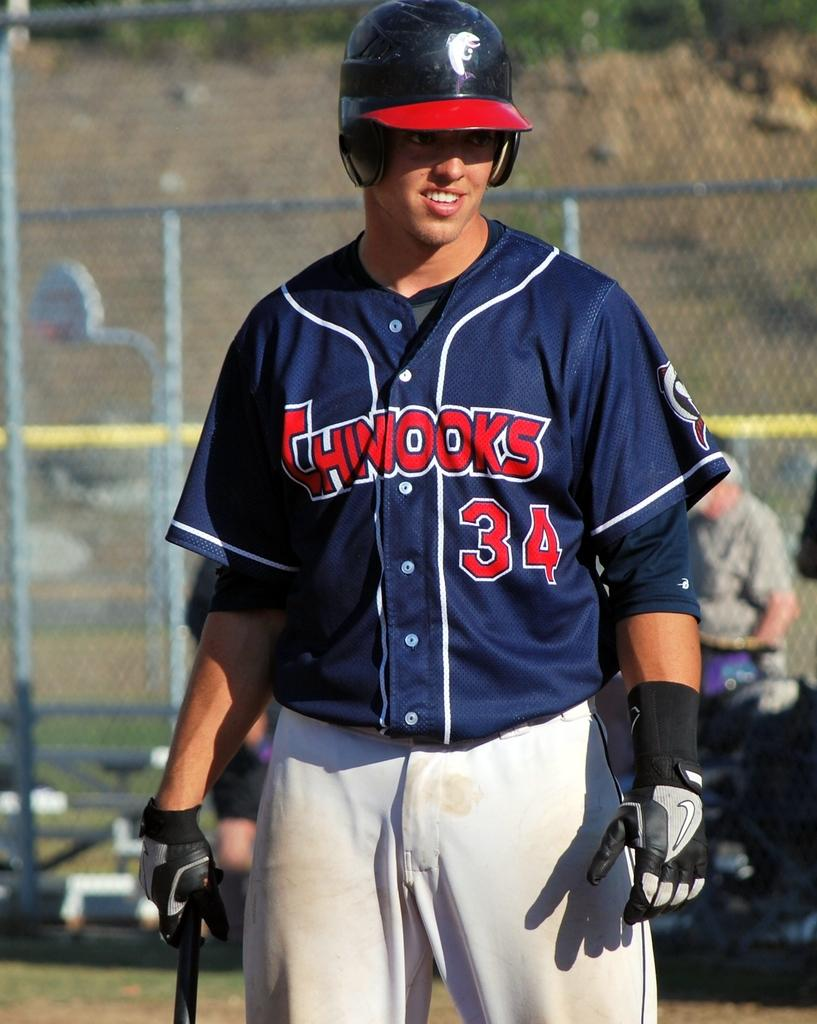<image>
Provide a brief description of the given image. a man standing with a jersey that is the number 34 